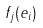Convert formula to latex. <formula><loc_0><loc_0><loc_500><loc_500>f _ { j } ( e _ { i } )</formula> 